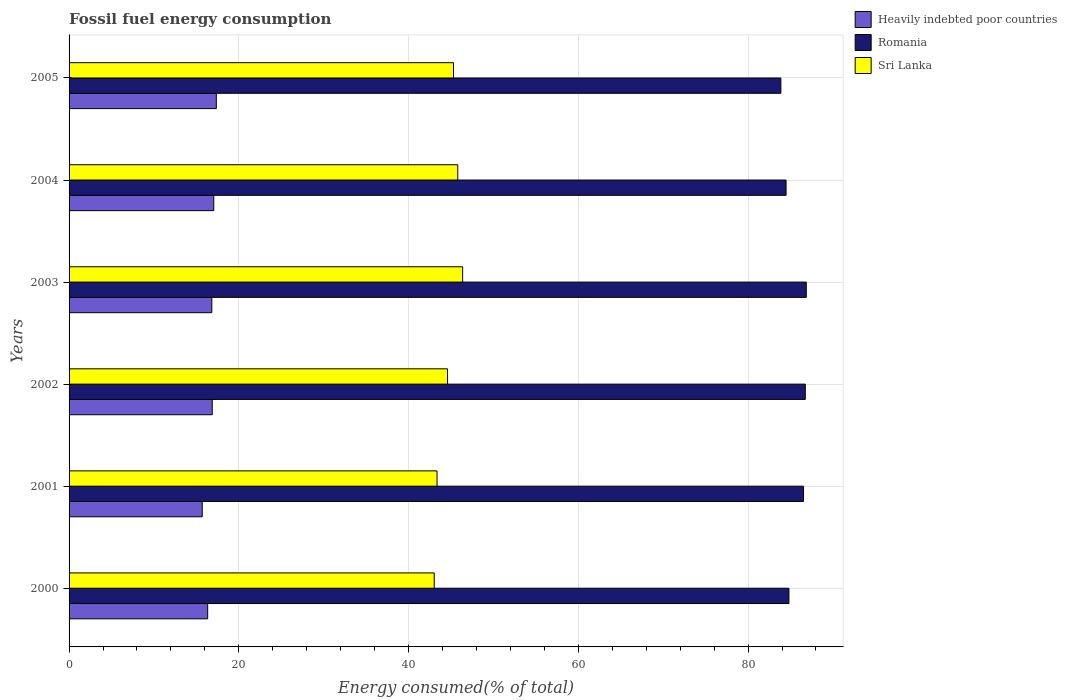How many different coloured bars are there?
Ensure brevity in your answer.  3. How many groups of bars are there?
Your answer should be very brief. 6. How many bars are there on the 3rd tick from the bottom?
Give a very brief answer. 3. What is the label of the 6th group of bars from the top?
Your answer should be compact. 2000. What is the percentage of energy consumed in Romania in 2005?
Provide a succinct answer. 83.87. Across all years, what is the maximum percentage of energy consumed in Heavily indebted poor countries?
Offer a terse response. 17.35. Across all years, what is the minimum percentage of energy consumed in Heavily indebted poor countries?
Keep it short and to the point. 15.69. In which year was the percentage of energy consumed in Sri Lanka maximum?
Your answer should be compact. 2003. In which year was the percentage of energy consumed in Sri Lanka minimum?
Ensure brevity in your answer.  2000. What is the total percentage of energy consumed in Sri Lanka in the graph?
Provide a short and direct response. 268.44. What is the difference between the percentage of energy consumed in Sri Lanka in 2004 and that in 2005?
Make the answer very short. 0.5. What is the difference between the percentage of energy consumed in Romania in 2004 and the percentage of energy consumed in Heavily indebted poor countries in 2000?
Your answer should be compact. 68.15. What is the average percentage of energy consumed in Sri Lanka per year?
Your answer should be compact. 44.74. In the year 2002, what is the difference between the percentage of energy consumed in Sri Lanka and percentage of energy consumed in Romania?
Your answer should be compact. -42.15. What is the ratio of the percentage of energy consumed in Romania in 2002 to that in 2003?
Your response must be concise. 1. Is the percentage of energy consumed in Sri Lanka in 2004 less than that in 2005?
Your answer should be very brief. No. Is the difference between the percentage of energy consumed in Sri Lanka in 2000 and 2004 greater than the difference between the percentage of energy consumed in Romania in 2000 and 2004?
Offer a terse response. No. What is the difference between the highest and the second highest percentage of energy consumed in Heavily indebted poor countries?
Provide a short and direct response. 0.3. What is the difference between the highest and the lowest percentage of energy consumed in Romania?
Your response must be concise. 2.99. What does the 2nd bar from the top in 2004 represents?
Offer a very short reply. Romania. What does the 2nd bar from the bottom in 2005 represents?
Ensure brevity in your answer.  Romania. How many bars are there?
Your answer should be compact. 18. How many years are there in the graph?
Give a very brief answer. 6. What is the difference between two consecutive major ticks on the X-axis?
Make the answer very short. 20. Does the graph contain any zero values?
Your response must be concise. No. Does the graph contain grids?
Offer a terse response. Yes. Where does the legend appear in the graph?
Provide a succinct answer. Top right. How many legend labels are there?
Keep it short and to the point. 3. What is the title of the graph?
Keep it short and to the point. Fossil fuel energy consumption. What is the label or title of the X-axis?
Offer a terse response. Energy consumed(% of total). What is the Energy consumed(% of total) of Heavily indebted poor countries in 2000?
Offer a very short reply. 16.33. What is the Energy consumed(% of total) in Romania in 2000?
Keep it short and to the point. 84.82. What is the Energy consumed(% of total) in Sri Lanka in 2000?
Ensure brevity in your answer.  43.03. What is the Energy consumed(% of total) in Heavily indebted poor countries in 2001?
Provide a succinct answer. 15.69. What is the Energy consumed(% of total) in Romania in 2001?
Your answer should be very brief. 86.53. What is the Energy consumed(% of total) in Sri Lanka in 2001?
Keep it short and to the point. 43.36. What is the Energy consumed(% of total) of Heavily indebted poor countries in 2002?
Provide a succinct answer. 16.87. What is the Energy consumed(% of total) of Romania in 2002?
Make the answer very short. 86.74. What is the Energy consumed(% of total) of Sri Lanka in 2002?
Offer a very short reply. 44.59. What is the Energy consumed(% of total) of Heavily indebted poor countries in 2003?
Ensure brevity in your answer.  16.82. What is the Energy consumed(% of total) in Romania in 2003?
Offer a terse response. 86.86. What is the Energy consumed(% of total) of Sri Lanka in 2003?
Give a very brief answer. 46.37. What is the Energy consumed(% of total) of Heavily indebted poor countries in 2004?
Make the answer very short. 17.05. What is the Energy consumed(% of total) in Romania in 2004?
Keep it short and to the point. 84.48. What is the Energy consumed(% of total) in Sri Lanka in 2004?
Your answer should be compact. 45.8. What is the Energy consumed(% of total) of Heavily indebted poor countries in 2005?
Your response must be concise. 17.35. What is the Energy consumed(% of total) in Romania in 2005?
Make the answer very short. 83.87. What is the Energy consumed(% of total) of Sri Lanka in 2005?
Your answer should be compact. 45.29. Across all years, what is the maximum Energy consumed(% of total) in Heavily indebted poor countries?
Ensure brevity in your answer.  17.35. Across all years, what is the maximum Energy consumed(% of total) in Romania?
Your answer should be compact. 86.86. Across all years, what is the maximum Energy consumed(% of total) in Sri Lanka?
Ensure brevity in your answer.  46.37. Across all years, what is the minimum Energy consumed(% of total) in Heavily indebted poor countries?
Offer a terse response. 15.69. Across all years, what is the minimum Energy consumed(% of total) of Romania?
Keep it short and to the point. 83.87. Across all years, what is the minimum Energy consumed(% of total) in Sri Lanka?
Provide a succinct answer. 43.03. What is the total Energy consumed(% of total) of Heavily indebted poor countries in the graph?
Keep it short and to the point. 100.1. What is the total Energy consumed(% of total) of Romania in the graph?
Offer a very short reply. 513.3. What is the total Energy consumed(% of total) in Sri Lanka in the graph?
Provide a short and direct response. 268.44. What is the difference between the Energy consumed(% of total) of Heavily indebted poor countries in 2000 and that in 2001?
Provide a succinct answer. 0.64. What is the difference between the Energy consumed(% of total) in Romania in 2000 and that in 2001?
Give a very brief answer. -1.72. What is the difference between the Energy consumed(% of total) in Sri Lanka in 2000 and that in 2001?
Ensure brevity in your answer.  -0.33. What is the difference between the Energy consumed(% of total) of Heavily indebted poor countries in 2000 and that in 2002?
Offer a terse response. -0.54. What is the difference between the Energy consumed(% of total) of Romania in 2000 and that in 2002?
Your response must be concise. -1.93. What is the difference between the Energy consumed(% of total) of Sri Lanka in 2000 and that in 2002?
Your answer should be very brief. -1.57. What is the difference between the Energy consumed(% of total) of Heavily indebted poor countries in 2000 and that in 2003?
Offer a very short reply. -0.49. What is the difference between the Energy consumed(% of total) in Romania in 2000 and that in 2003?
Offer a terse response. -2.04. What is the difference between the Energy consumed(% of total) in Sri Lanka in 2000 and that in 2003?
Offer a terse response. -3.35. What is the difference between the Energy consumed(% of total) of Heavily indebted poor countries in 2000 and that in 2004?
Provide a short and direct response. -0.72. What is the difference between the Energy consumed(% of total) of Romania in 2000 and that in 2004?
Provide a short and direct response. 0.34. What is the difference between the Energy consumed(% of total) of Sri Lanka in 2000 and that in 2004?
Make the answer very short. -2.77. What is the difference between the Energy consumed(% of total) of Heavily indebted poor countries in 2000 and that in 2005?
Keep it short and to the point. -1.02. What is the difference between the Energy consumed(% of total) in Romania in 2000 and that in 2005?
Provide a succinct answer. 0.95. What is the difference between the Energy consumed(% of total) of Sri Lanka in 2000 and that in 2005?
Provide a short and direct response. -2.27. What is the difference between the Energy consumed(% of total) in Heavily indebted poor countries in 2001 and that in 2002?
Provide a short and direct response. -1.18. What is the difference between the Energy consumed(% of total) in Romania in 2001 and that in 2002?
Ensure brevity in your answer.  -0.21. What is the difference between the Energy consumed(% of total) of Sri Lanka in 2001 and that in 2002?
Offer a terse response. -1.24. What is the difference between the Energy consumed(% of total) of Heavily indebted poor countries in 2001 and that in 2003?
Offer a very short reply. -1.13. What is the difference between the Energy consumed(% of total) of Romania in 2001 and that in 2003?
Your response must be concise. -0.33. What is the difference between the Energy consumed(% of total) of Sri Lanka in 2001 and that in 2003?
Your answer should be very brief. -3.02. What is the difference between the Energy consumed(% of total) in Heavily indebted poor countries in 2001 and that in 2004?
Provide a short and direct response. -1.36. What is the difference between the Energy consumed(% of total) of Romania in 2001 and that in 2004?
Ensure brevity in your answer.  2.06. What is the difference between the Energy consumed(% of total) of Sri Lanka in 2001 and that in 2004?
Ensure brevity in your answer.  -2.44. What is the difference between the Energy consumed(% of total) in Heavily indebted poor countries in 2001 and that in 2005?
Your answer should be very brief. -1.66. What is the difference between the Energy consumed(% of total) of Romania in 2001 and that in 2005?
Offer a very short reply. 2.67. What is the difference between the Energy consumed(% of total) in Sri Lanka in 2001 and that in 2005?
Provide a succinct answer. -1.94. What is the difference between the Energy consumed(% of total) of Heavily indebted poor countries in 2002 and that in 2003?
Provide a short and direct response. 0.05. What is the difference between the Energy consumed(% of total) in Romania in 2002 and that in 2003?
Provide a short and direct response. -0.12. What is the difference between the Energy consumed(% of total) of Sri Lanka in 2002 and that in 2003?
Make the answer very short. -1.78. What is the difference between the Energy consumed(% of total) in Heavily indebted poor countries in 2002 and that in 2004?
Offer a terse response. -0.18. What is the difference between the Energy consumed(% of total) of Romania in 2002 and that in 2004?
Your answer should be very brief. 2.27. What is the difference between the Energy consumed(% of total) of Sri Lanka in 2002 and that in 2004?
Offer a terse response. -1.2. What is the difference between the Energy consumed(% of total) in Heavily indebted poor countries in 2002 and that in 2005?
Ensure brevity in your answer.  -0.48. What is the difference between the Energy consumed(% of total) in Romania in 2002 and that in 2005?
Provide a short and direct response. 2.88. What is the difference between the Energy consumed(% of total) of Sri Lanka in 2002 and that in 2005?
Ensure brevity in your answer.  -0.7. What is the difference between the Energy consumed(% of total) in Heavily indebted poor countries in 2003 and that in 2004?
Your answer should be compact. -0.23. What is the difference between the Energy consumed(% of total) in Romania in 2003 and that in 2004?
Keep it short and to the point. 2.38. What is the difference between the Energy consumed(% of total) in Sri Lanka in 2003 and that in 2004?
Offer a very short reply. 0.57. What is the difference between the Energy consumed(% of total) in Heavily indebted poor countries in 2003 and that in 2005?
Provide a short and direct response. -0.53. What is the difference between the Energy consumed(% of total) of Romania in 2003 and that in 2005?
Provide a short and direct response. 2.99. What is the difference between the Energy consumed(% of total) of Sri Lanka in 2003 and that in 2005?
Keep it short and to the point. 1.08. What is the difference between the Energy consumed(% of total) in Heavily indebted poor countries in 2004 and that in 2005?
Make the answer very short. -0.3. What is the difference between the Energy consumed(% of total) in Romania in 2004 and that in 2005?
Your answer should be compact. 0.61. What is the difference between the Energy consumed(% of total) in Sri Lanka in 2004 and that in 2005?
Your response must be concise. 0.5. What is the difference between the Energy consumed(% of total) of Heavily indebted poor countries in 2000 and the Energy consumed(% of total) of Romania in 2001?
Offer a very short reply. -70.2. What is the difference between the Energy consumed(% of total) in Heavily indebted poor countries in 2000 and the Energy consumed(% of total) in Sri Lanka in 2001?
Keep it short and to the point. -27.03. What is the difference between the Energy consumed(% of total) in Romania in 2000 and the Energy consumed(% of total) in Sri Lanka in 2001?
Provide a short and direct response. 41.46. What is the difference between the Energy consumed(% of total) in Heavily indebted poor countries in 2000 and the Energy consumed(% of total) in Romania in 2002?
Ensure brevity in your answer.  -70.41. What is the difference between the Energy consumed(% of total) in Heavily indebted poor countries in 2000 and the Energy consumed(% of total) in Sri Lanka in 2002?
Provide a short and direct response. -28.26. What is the difference between the Energy consumed(% of total) in Romania in 2000 and the Energy consumed(% of total) in Sri Lanka in 2002?
Make the answer very short. 40.22. What is the difference between the Energy consumed(% of total) in Heavily indebted poor countries in 2000 and the Energy consumed(% of total) in Romania in 2003?
Keep it short and to the point. -70.53. What is the difference between the Energy consumed(% of total) of Heavily indebted poor countries in 2000 and the Energy consumed(% of total) of Sri Lanka in 2003?
Your answer should be compact. -30.04. What is the difference between the Energy consumed(% of total) in Romania in 2000 and the Energy consumed(% of total) in Sri Lanka in 2003?
Your response must be concise. 38.44. What is the difference between the Energy consumed(% of total) of Heavily indebted poor countries in 2000 and the Energy consumed(% of total) of Romania in 2004?
Your answer should be compact. -68.15. What is the difference between the Energy consumed(% of total) of Heavily indebted poor countries in 2000 and the Energy consumed(% of total) of Sri Lanka in 2004?
Ensure brevity in your answer.  -29.47. What is the difference between the Energy consumed(% of total) in Romania in 2000 and the Energy consumed(% of total) in Sri Lanka in 2004?
Offer a terse response. 39.02. What is the difference between the Energy consumed(% of total) of Heavily indebted poor countries in 2000 and the Energy consumed(% of total) of Romania in 2005?
Provide a succinct answer. -67.54. What is the difference between the Energy consumed(% of total) of Heavily indebted poor countries in 2000 and the Energy consumed(% of total) of Sri Lanka in 2005?
Keep it short and to the point. -28.96. What is the difference between the Energy consumed(% of total) in Romania in 2000 and the Energy consumed(% of total) in Sri Lanka in 2005?
Ensure brevity in your answer.  39.52. What is the difference between the Energy consumed(% of total) of Heavily indebted poor countries in 2001 and the Energy consumed(% of total) of Romania in 2002?
Offer a very short reply. -71.06. What is the difference between the Energy consumed(% of total) of Heavily indebted poor countries in 2001 and the Energy consumed(% of total) of Sri Lanka in 2002?
Give a very brief answer. -28.9. What is the difference between the Energy consumed(% of total) in Romania in 2001 and the Energy consumed(% of total) in Sri Lanka in 2002?
Offer a terse response. 41.94. What is the difference between the Energy consumed(% of total) of Heavily indebted poor countries in 2001 and the Energy consumed(% of total) of Romania in 2003?
Your answer should be compact. -71.17. What is the difference between the Energy consumed(% of total) of Heavily indebted poor countries in 2001 and the Energy consumed(% of total) of Sri Lanka in 2003?
Your answer should be compact. -30.68. What is the difference between the Energy consumed(% of total) in Romania in 2001 and the Energy consumed(% of total) in Sri Lanka in 2003?
Offer a very short reply. 40.16. What is the difference between the Energy consumed(% of total) in Heavily indebted poor countries in 2001 and the Energy consumed(% of total) in Romania in 2004?
Ensure brevity in your answer.  -68.79. What is the difference between the Energy consumed(% of total) in Heavily indebted poor countries in 2001 and the Energy consumed(% of total) in Sri Lanka in 2004?
Keep it short and to the point. -30.11. What is the difference between the Energy consumed(% of total) in Romania in 2001 and the Energy consumed(% of total) in Sri Lanka in 2004?
Provide a short and direct response. 40.74. What is the difference between the Energy consumed(% of total) of Heavily indebted poor countries in 2001 and the Energy consumed(% of total) of Romania in 2005?
Ensure brevity in your answer.  -68.18. What is the difference between the Energy consumed(% of total) in Heavily indebted poor countries in 2001 and the Energy consumed(% of total) in Sri Lanka in 2005?
Your answer should be compact. -29.6. What is the difference between the Energy consumed(% of total) of Romania in 2001 and the Energy consumed(% of total) of Sri Lanka in 2005?
Make the answer very short. 41.24. What is the difference between the Energy consumed(% of total) of Heavily indebted poor countries in 2002 and the Energy consumed(% of total) of Romania in 2003?
Offer a terse response. -69.99. What is the difference between the Energy consumed(% of total) of Heavily indebted poor countries in 2002 and the Energy consumed(% of total) of Sri Lanka in 2003?
Offer a very short reply. -29.5. What is the difference between the Energy consumed(% of total) of Romania in 2002 and the Energy consumed(% of total) of Sri Lanka in 2003?
Your answer should be very brief. 40.37. What is the difference between the Energy consumed(% of total) in Heavily indebted poor countries in 2002 and the Energy consumed(% of total) in Romania in 2004?
Give a very brief answer. -67.61. What is the difference between the Energy consumed(% of total) of Heavily indebted poor countries in 2002 and the Energy consumed(% of total) of Sri Lanka in 2004?
Keep it short and to the point. -28.93. What is the difference between the Energy consumed(% of total) in Romania in 2002 and the Energy consumed(% of total) in Sri Lanka in 2004?
Make the answer very short. 40.95. What is the difference between the Energy consumed(% of total) in Heavily indebted poor countries in 2002 and the Energy consumed(% of total) in Romania in 2005?
Keep it short and to the point. -67. What is the difference between the Energy consumed(% of total) of Heavily indebted poor countries in 2002 and the Energy consumed(% of total) of Sri Lanka in 2005?
Your answer should be compact. -28.43. What is the difference between the Energy consumed(% of total) in Romania in 2002 and the Energy consumed(% of total) in Sri Lanka in 2005?
Ensure brevity in your answer.  41.45. What is the difference between the Energy consumed(% of total) of Heavily indebted poor countries in 2003 and the Energy consumed(% of total) of Romania in 2004?
Your response must be concise. -67.66. What is the difference between the Energy consumed(% of total) in Heavily indebted poor countries in 2003 and the Energy consumed(% of total) in Sri Lanka in 2004?
Keep it short and to the point. -28.98. What is the difference between the Energy consumed(% of total) of Romania in 2003 and the Energy consumed(% of total) of Sri Lanka in 2004?
Offer a terse response. 41.06. What is the difference between the Energy consumed(% of total) in Heavily indebted poor countries in 2003 and the Energy consumed(% of total) in Romania in 2005?
Your response must be concise. -67.05. What is the difference between the Energy consumed(% of total) in Heavily indebted poor countries in 2003 and the Energy consumed(% of total) in Sri Lanka in 2005?
Ensure brevity in your answer.  -28.48. What is the difference between the Energy consumed(% of total) in Romania in 2003 and the Energy consumed(% of total) in Sri Lanka in 2005?
Your response must be concise. 41.57. What is the difference between the Energy consumed(% of total) in Heavily indebted poor countries in 2004 and the Energy consumed(% of total) in Romania in 2005?
Keep it short and to the point. -66.82. What is the difference between the Energy consumed(% of total) of Heavily indebted poor countries in 2004 and the Energy consumed(% of total) of Sri Lanka in 2005?
Your response must be concise. -28.25. What is the difference between the Energy consumed(% of total) in Romania in 2004 and the Energy consumed(% of total) in Sri Lanka in 2005?
Offer a very short reply. 39.18. What is the average Energy consumed(% of total) of Heavily indebted poor countries per year?
Your answer should be compact. 16.68. What is the average Energy consumed(% of total) in Romania per year?
Offer a terse response. 85.55. What is the average Energy consumed(% of total) of Sri Lanka per year?
Ensure brevity in your answer.  44.74. In the year 2000, what is the difference between the Energy consumed(% of total) in Heavily indebted poor countries and Energy consumed(% of total) in Romania?
Keep it short and to the point. -68.49. In the year 2000, what is the difference between the Energy consumed(% of total) of Heavily indebted poor countries and Energy consumed(% of total) of Sri Lanka?
Provide a short and direct response. -26.69. In the year 2000, what is the difference between the Energy consumed(% of total) of Romania and Energy consumed(% of total) of Sri Lanka?
Ensure brevity in your answer.  41.79. In the year 2001, what is the difference between the Energy consumed(% of total) of Heavily indebted poor countries and Energy consumed(% of total) of Romania?
Your answer should be very brief. -70.85. In the year 2001, what is the difference between the Energy consumed(% of total) in Heavily indebted poor countries and Energy consumed(% of total) in Sri Lanka?
Ensure brevity in your answer.  -27.67. In the year 2001, what is the difference between the Energy consumed(% of total) of Romania and Energy consumed(% of total) of Sri Lanka?
Your answer should be very brief. 43.18. In the year 2002, what is the difference between the Energy consumed(% of total) in Heavily indebted poor countries and Energy consumed(% of total) in Romania?
Provide a succinct answer. -69.88. In the year 2002, what is the difference between the Energy consumed(% of total) of Heavily indebted poor countries and Energy consumed(% of total) of Sri Lanka?
Provide a short and direct response. -27.73. In the year 2002, what is the difference between the Energy consumed(% of total) in Romania and Energy consumed(% of total) in Sri Lanka?
Make the answer very short. 42.15. In the year 2003, what is the difference between the Energy consumed(% of total) of Heavily indebted poor countries and Energy consumed(% of total) of Romania?
Make the answer very short. -70.04. In the year 2003, what is the difference between the Energy consumed(% of total) of Heavily indebted poor countries and Energy consumed(% of total) of Sri Lanka?
Your response must be concise. -29.55. In the year 2003, what is the difference between the Energy consumed(% of total) in Romania and Energy consumed(% of total) in Sri Lanka?
Give a very brief answer. 40.49. In the year 2004, what is the difference between the Energy consumed(% of total) of Heavily indebted poor countries and Energy consumed(% of total) of Romania?
Your answer should be compact. -67.43. In the year 2004, what is the difference between the Energy consumed(% of total) in Heavily indebted poor countries and Energy consumed(% of total) in Sri Lanka?
Your response must be concise. -28.75. In the year 2004, what is the difference between the Energy consumed(% of total) in Romania and Energy consumed(% of total) in Sri Lanka?
Your answer should be very brief. 38.68. In the year 2005, what is the difference between the Energy consumed(% of total) of Heavily indebted poor countries and Energy consumed(% of total) of Romania?
Ensure brevity in your answer.  -66.52. In the year 2005, what is the difference between the Energy consumed(% of total) of Heavily indebted poor countries and Energy consumed(% of total) of Sri Lanka?
Provide a succinct answer. -27.94. In the year 2005, what is the difference between the Energy consumed(% of total) of Romania and Energy consumed(% of total) of Sri Lanka?
Keep it short and to the point. 38.57. What is the ratio of the Energy consumed(% of total) in Heavily indebted poor countries in 2000 to that in 2001?
Ensure brevity in your answer.  1.04. What is the ratio of the Energy consumed(% of total) of Romania in 2000 to that in 2001?
Your answer should be very brief. 0.98. What is the ratio of the Energy consumed(% of total) in Sri Lanka in 2000 to that in 2001?
Your response must be concise. 0.99. What is the ratio of the Energy consumed(% of total) in Heavily indebted poor countries in 2000 to that in 2002?
Give a very brief answer. 0.97. What is the ratio of the Energy consumed(% of total) of Romania in 2000 to that in 2002?
Provide a succinct answer. 0.98. What is the ratio of the Energy consumed(% of total) in Sri Lanka in 2000 to that in 2002?
Keep it short and to the point. 0.96. What is the ratio of the Energy consumed(% of total) of Heavily indebted poor countries in 2000 to that in 2003?
Give a very brief answer. 0.97. What is the ratio of the Energy consumed(% of total) of Romania in 2000 to that in 2003?
Keep it short and to the point. 0.98. What is the ratio of the Energy consumed(% of total) in Sri Lanka in 2000 to that in 2003?
Keep it short and to the point. 0.93. What is the ratio of the Energy consumed(% of total) in Heavily indebted poor countries in 2000 to that in 2004?
Provide a short and direct response. 0.96. What is the ratio of the Energy consumed(% of total) in Romania in 2000 to that in 2004?
Offer a very short reply. 1. What is the ratio of the Energy consumed(% of total) of Sri Lanka in 2000 to that in 2004?
Give a very brief answer. 0.94. What is the ratio of the Energy consumed(% of total) in Heavily indebted poor countries in 2000 to that in 2005?
Offer a very short reply. 0.94. What is the ratio of the Energy consumed(% of total) of Romania in 2000 to that in 2005?
Your response must be concise. 1.01. What is the ratio of the Energy consumed(% of total) in Sri Lanka in 2000 to that in 2005?
Your response must be concise. 0.95. What is the ratio of the Energy consumed(% of total) in Heavily indebted poor countries in 2001 to that in 2002?
Your response must be concise. 0.93. What is the ratio of the Energy consumed(% of total) of Sri Lanka in 2001 to that in 2002?
Give a very brief answer. 0.97. What is the ratio of the Energy consumed(% of total) of Heavily indebted poor countries in 2001 to that in 2003?
Make the answer very short. 0.93. What is the ratio of the Energy consumed(% of total) in Romania in 2001 to that in 2003?
Your answer should be compact. 1. What is the ratio of the Energy consumed(% of total) of Sri Lanka in 2001 to that in 2003?
Make the answer very short. 0.94. What is the ratio of the Energy consumed(% of total) in Heavily indebted poor countries in 2001 to that in 2004?
Give a very brief answer. 0.92. What is the ratio of the Energy consumed(% of total) in Romania in 2001 to that in 2004?
Ensure brevity in your answer.  1.02. What is the ratio of the Energy consumed(% of total) of Sri Lanka in 2001 to that in 2004?
Your response must be concise. 0.95. What is the ratio of the Energy consumed(% of total) in Heavily indebted poor countries in 2001 to that in 2005?
Your answer should be compact. 0.9. What is the ratio of the Energy consumed(% of total) of Romania in 2001 to that in 2005?
Give a very brief answer. 1.03. What is the ratio of the Energy consumed(% of total) in Sri Lanka in 2001 to that in 2005?
Your response must be concise. 0.96. What is the ratio of the Energy consumed(% of total) in Sri Lanka in 2002 to that in 2003?
Give a very brief answer. 0.96. What is the ratio of the Energy consumed(% of total) of Romania in 2002 to that in 2004?
Make the answer very short. 1.03. What is the ratio of the Energy consumed(% of total) of Sri Lanka in 2002 to that in 2004?
Your answer should be compact. 0.97. What is the ratio of the Energy consumed(% of total) in Heavily indebted poor countries in 2002 to that in 2005?
Offer a very short reply. 0.97. What is the ratio of the Energy consumed(% of total) of Romania in 2002 to that in 2005?
Provide a succinct answer. 1.03. What is the ratio of the Energy consumed(% of total) of Sri Lanka in 2002 to that in 2005?
Make the answer very short. 0.98. What is the ratio of the Energy consumed(% of total) in Heavily indebted poor countries in 2003 to that in 2004?
Your answer should be compact. 0.99. What is the ratio of the Energy consumed(% of total) in Romania in 2003 to that in 2004?
Make the answer very short. 1.03. What is the ratio of the Energy consumed(% of total) of Sri Lanka in 2003 to that in 2004?
Provide a succinct answer. 1.01. What is the ratio of the Energy consumed(% of total) of Heavily indebted poor countries in 2003 to that in 2005?
Provide a short and direct response. 0.97. What is the ratio of the Energy consumed(% of total) in Romania in 2003 to that in 2005?
Offer a very short reply. 1.04. What is the ratio of the Energy consumed(% of total) of Sri Lanka in 2003 to that in 2005?
Give a very brief answer. 1.02. What is the ratio of the Energy consumed(% of total) of Heavily indebted poor countries in 2004 to that in 2005?
Keep it short and to the point. 0.98. What is the ratio of the Energy consumed(% of total) of Romania in 2004 to that in 2005?
Your answer should be very brief. 1.01. What is the ratio of the Energy consumed(% of total) in Sri Lanka in 2004 to that in 2005?
Make the answer very short. 1.01. What is the difference between the highest and the second highest Energy consumed(% of total) in Heavily indebted poor countries?
Ensure brevity in your answer.  0.3. What is the difference between the highest and the second highest Energy consumed(% of total) in Romania?
Your answer should be compact. 0.12. What is the difference between the highest and the second highest Energy consumed(% of total) in Sri Lanka?
Provide a short and direct response. 0.57. What is the difference between the highest and the lowest Energy consumed(% of total) in Heavily indebted poor countries?
Make the answer very short. 1.66. What is the difference between the highest and the lowest Energy consumed(% of total) in Romania?
Give a very brief answer. 2.99. What is the difference between the highest and the lowest Energy consumed(% of total) of Sri Lanka?
Provide a short and direct response. 3.35. 